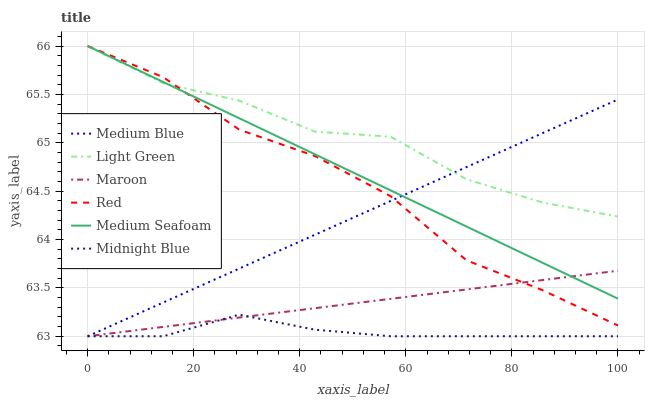Does Midnight Blue have the minimum area under the curve?
Answer yes or no. Yes. Does Light Green have the maximum area under the curve?
Answer yes or no. Yes. Does Medium Blue have the minimum area under the curve?
Answer yes or no. No. Does Medium Blue have the maximum area under the curve?
Answer yes or no. No. Is Maroon the smoothest?
Answer yes or no. Yes. Is Light Green the roughest?
Answer yes or no. Yes. Is Medium Blue the smoothest?
Answer yes or no. No. Is Medium Blue the roughest?
Answer yes or no. No. Does Midnight Blue have the lowest value?
Answer yes or no. Yes. Does Light Green have the lowest value?
Answer yes or no. No. Does Red have the highest value?
Answer yes or no. Yes. Does Medium Blue have the highest value?
Answer yes or no. No. Is Midnight Blue less than Light Green?
Answer yes or no. Yes. Is Light Green greater than Midnight Blue?
Answer yes or no. Yes. Does Medium Blue intersect Red?
Answer yes or no. Yes. Is Medium Blue less than Red?
Answer yes or no. No. Is Medium Blue greater than Red?
Answer yes or no. No. Does Midnight Blue intersect Light Green?
Answer yes or no. No. 